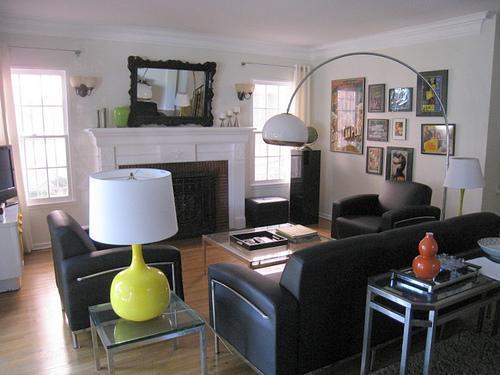How many people are in the room?
Give a very brief answer. 0. How many yellow lamps?
Give a very brief answer. 1. How many chairs are in the photo?
Give a very brief answer. 2. 